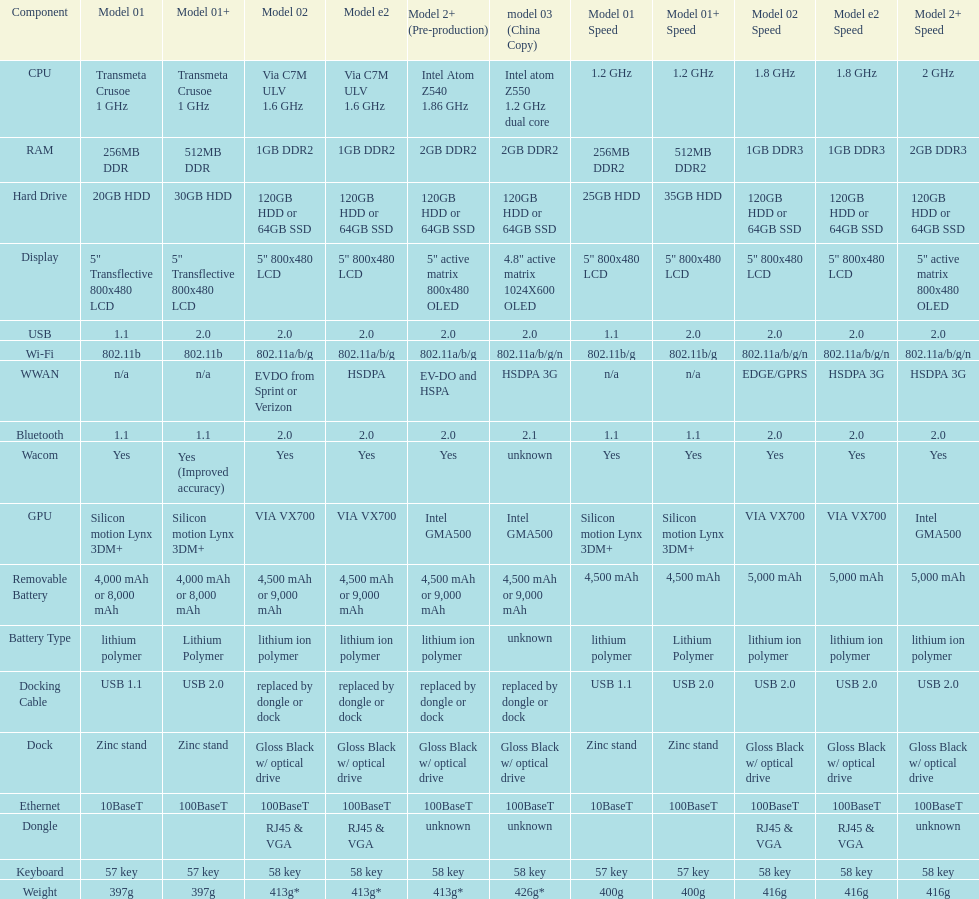Are there at least 13 different components on the chart? Yes. 